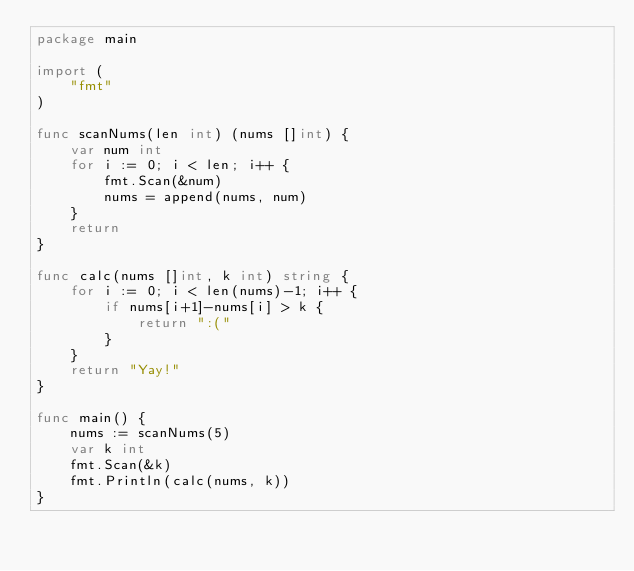Convert code to text. <code><loc_0><loc_0><loc_500><loc_500><_Go_>package main

import (
	"fmt"
)

func scanNums(len int) (nums []int) {
	var num int
	for i := 0; i < len; i++ {
		fmt.Scan(&num)
		nums = append(nums, num)
	}
	return
}

func calc(nums []int, k int) string {
	for i := 0; i < len(nums)-1; i++ {
		if nums[i+1]-nums[i] > k {
			return ":("
		}
	}
	return "Yay!"
}

func main() {
	nums := scanNums(5)
	var k int
	fmt.Scan(&k)
	fmt.Println(calc(nums, k))
}
</code> 